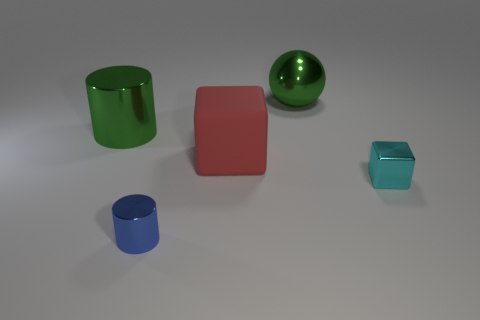What shape is the matte thing?
Provide a short and direct response. Cube. Is the shape of the large matte object the same as the big green metal object right of the red matte thing?
Your response must be concise. No. Do the tiny thing that is in front of the metal block and the large red thing have the same shape?
Offer a very short reply. No. How many metallic things are both to the right of the small blue metallic cylinder and in front of the big cylinder?
Your response must be concise. 1. How many other things are the same size as the sphere?
Keep it short and to the point. 2. Are there the same number of things that are on the left side of the blue metallic cylinder and big matte objects?
Your answer should be compact. Yes. There is a metal cylinder left of the tiny shiny cylinder; does it have the same color as the cylinder in front of the matte block?
Ensure brevity in your answer.  No. There is a thing that is both in front of the big sphere and to the right of the large block; what is its material?
Make the answer very short. Metal. What color is the tiny cube?
Keep it short and to the point. Cyan. Is the number of cyan objects that are behind the cyan metal thing the same as the number of large red matte blocks that are in front of the rubber block?
Your response must be concise. Yes. 